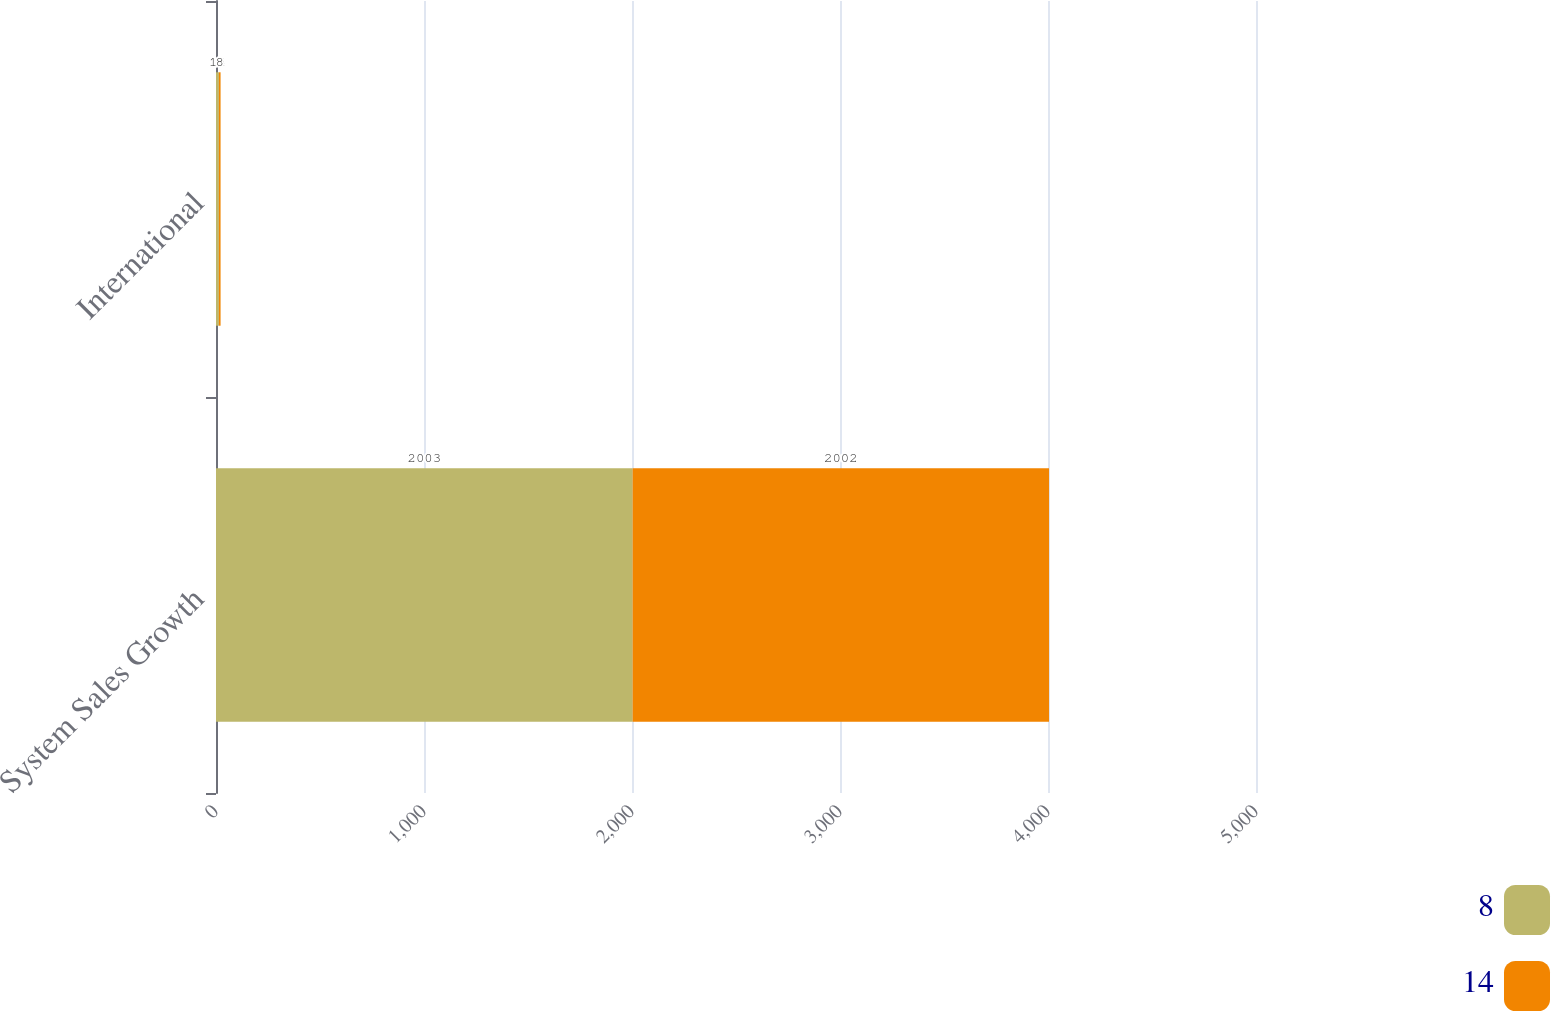Convert chart. <chart><loc_0><loc_0><loc_500><loc_500><stacked_bar_chart><ecel><fcel>System Sales Growth<fcel>International<nl><fcel>8<fcel>2003<fcel>14<nl><fcel>14<fcel>2002<fcel>8<nl></chart> 